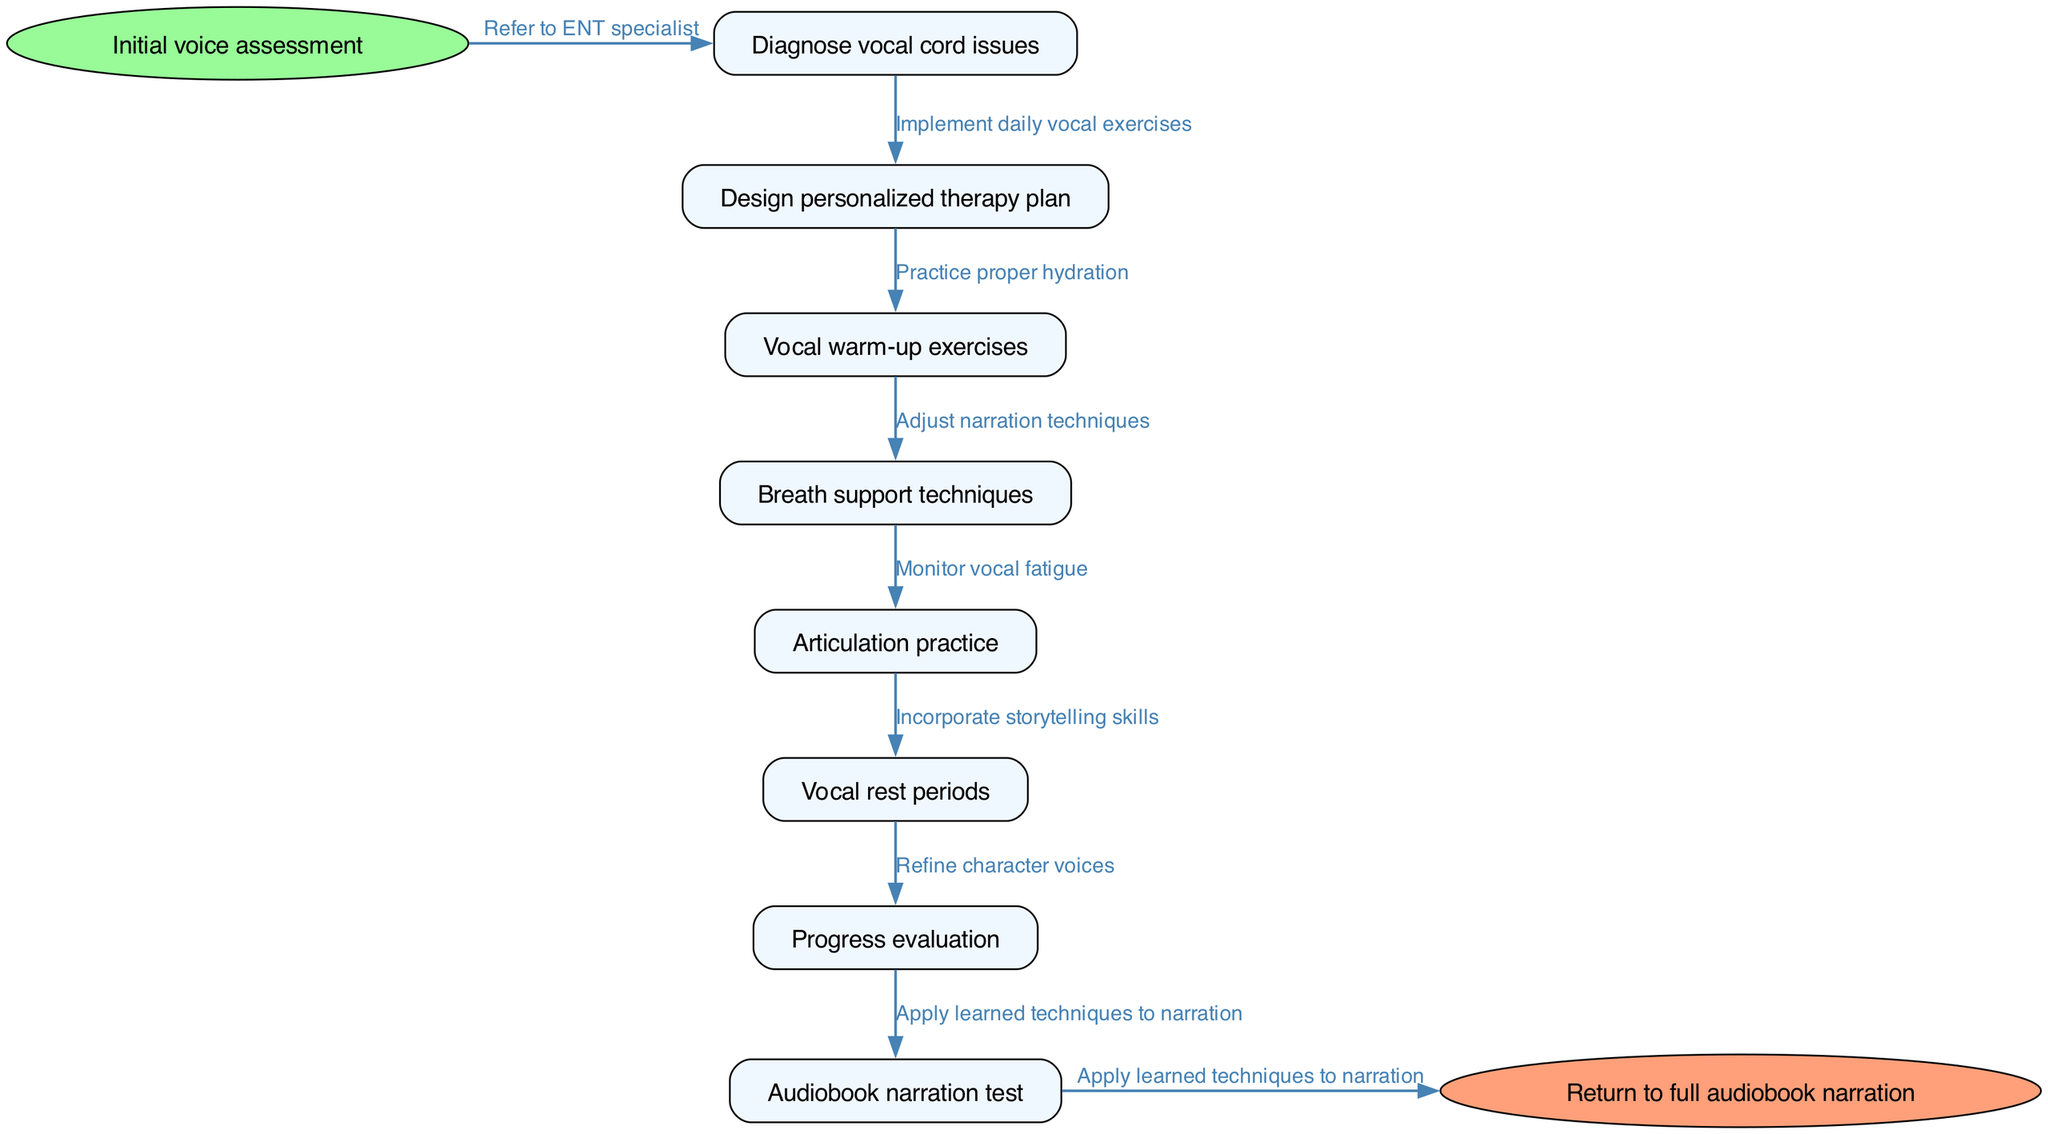What is the first step in the clinical pathway? The diagram begins with the "Initial voice assessment" as the starting point, which is the first step in the process.
Answer: Initial voice assessment How many nodes are there in the diagram? The diagram contains a total of 8 nodes, including the start and end nodes. The nodes listed are "Diagnose vocal cord issues," "Design personalized therapy plan," "Vocal warm-up exercises," "Breath support techniques," "Articulation practice," "Vocal rest periods," "Progress evaluation," and "Audiobook narration test."
Answer: 8 Which node comes after "Diagnose vocal cord issues"? Following the node "Diagnose vocal cord issues," the next step in the pathway is "Design personalized therapy plan," which directly succeeds it.
Answer: Design personalized therapy plan What type of techniques is included in the clinical pathway for audiobook narrators? The pathway focuses on "Breath support techniques," which are essential for improving vocal quality and endurance specific to audiobook narration.
Answer: Breath support techniques Which edge connects "Progress evaluation" to the next node? The edge connecting "Progress evaluation" to the following node is represented by "Apply learned techniques to narration," indicating that this step follows the evaluation of progress.
Answer: Apply learned techniques to narration What is the final step before returning to full audiobook narration? The step just before returning to full audiobook narration is "Audiobook narration test," indicating the need to assess the narrator's readiness for full performance.
Answer: Audiobook narration test How many edges connect the nodes in total? The total number of edges in the diagram is 8, as each edge represents the connections between the various steps outlined in the clinical pathway.
Answer: 8 What is one of the relationships indicated by edges in the pathway? One of the relationships indicated by the edges is "Implement daily vocal exercises," which shows the action taken after "Design personalized therapy plan."
Answer: Implement daily vocal exercises What type of rest periods are included in the voice therapy process? The clinical pathway includes "Vocal rest periods," which provide essential downtime for the vocal cords to recover during therapy.
Answer: Vocal rest periods 